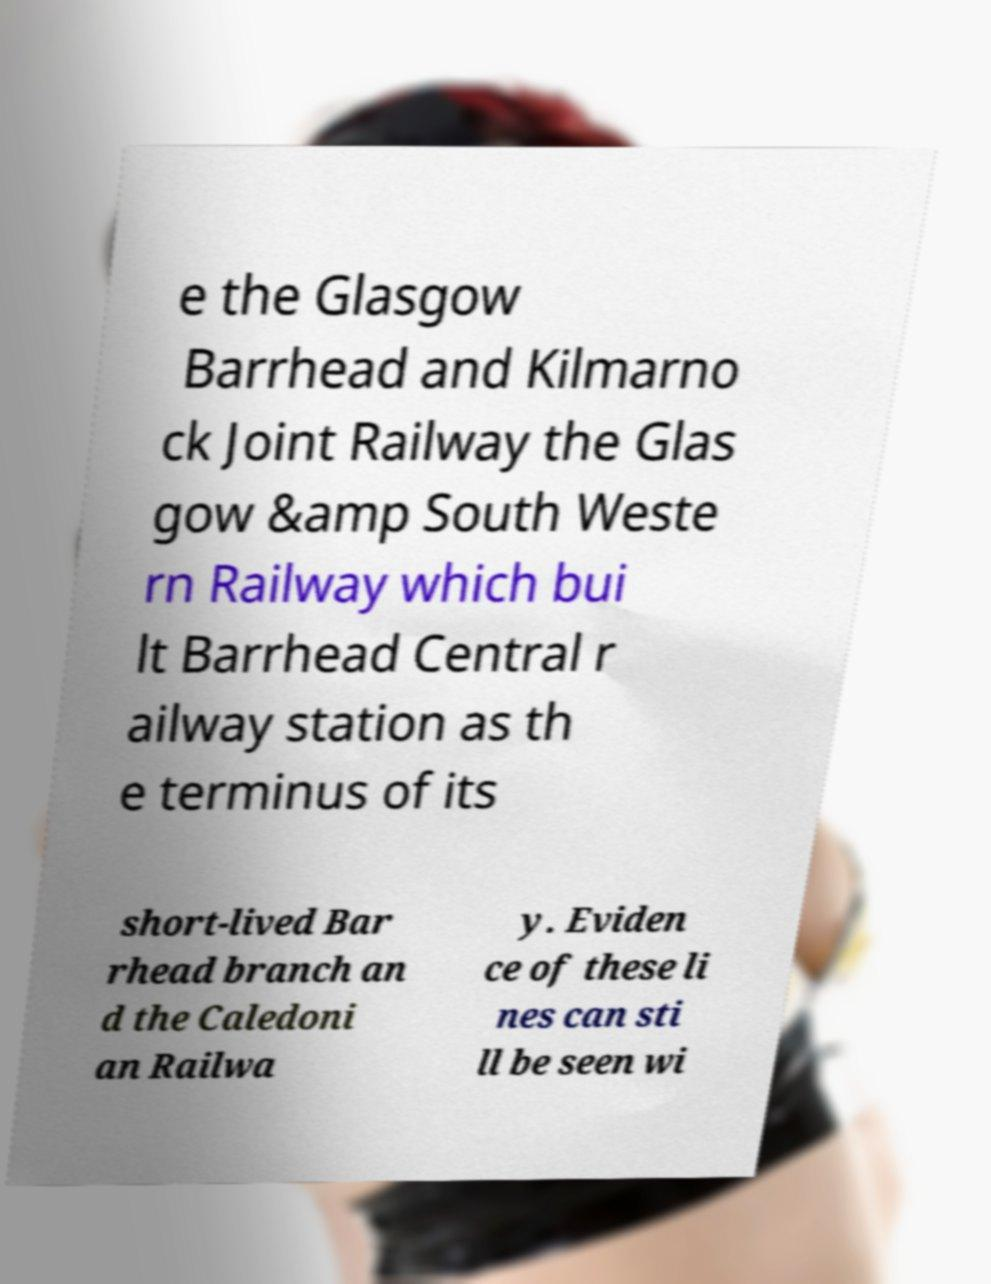Could you extract and type out the text from this image? e the Glasgow Barrhead and Kilmarno ck Joint Railway the Glas gow &amp South Weste rn Railway which bui lt Barrhead Central r ailway station as th e terminus of its short-lived Bar rhead branch an d the Caledoni an Railwa y. Eviden ce of these li nes can sti ll be seen wi 